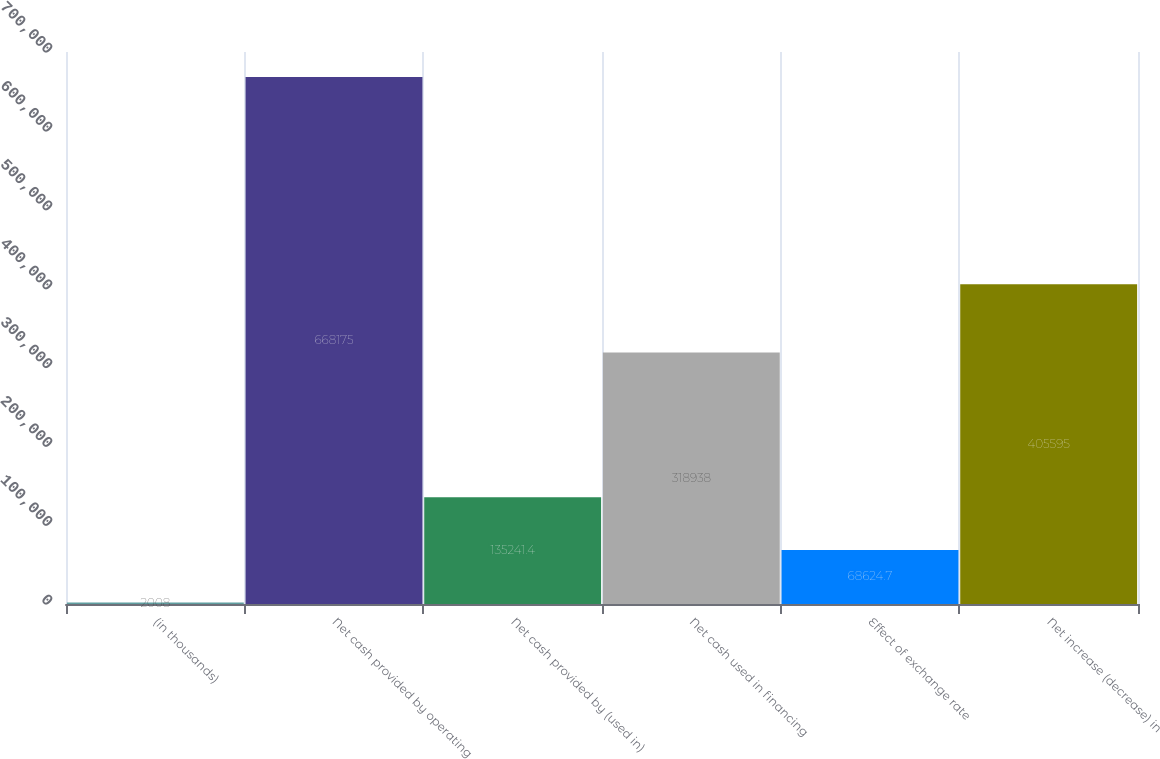Convert chart to OTSL. <chart><loc_0><loc_0><loc_500><loc_500><bar_chart><fcel>(in thousands)<fcel>Net cash provided by operating<fcel>Net cash provided by (used in)<fcel>Net cash used in financing<fcel>Effect of exchange rate<fcel>Net increase (decrease) in<nl><fcel>2008<fcel>668175<fcel>135241<fcel>318938<fcel>68624.7<fcel>405595<nl></chart> 